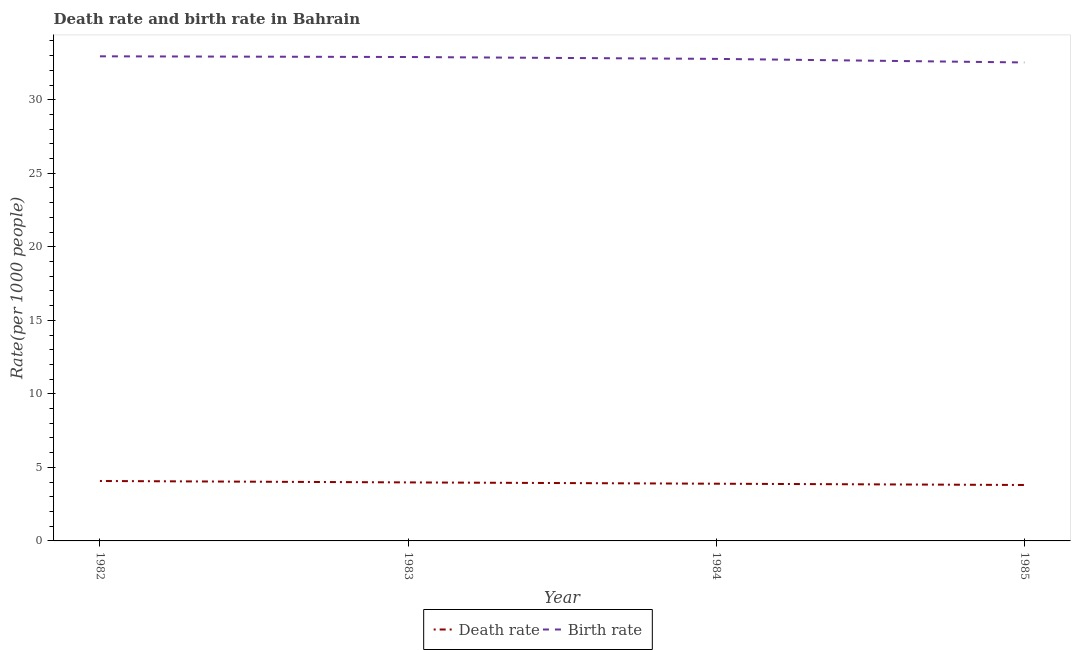Is the number of lines equal to the number of legend labels?
Your answer should be compact. Yes. What is the death rate in 1982?
Your answer should be very brief. 4.08. Across all years, what is the maximum birth rate?
Your response must be concise. 32.95. Across all years, what is the minimum birth rate?
Ensure brevity in your answer.  32.53. In which year was the birth rate minimum?
Make the answer very short. 1985. What is the total death rate in the graph?
Your answer should be compact. 15.75. What is the difference between the birth rate in 1982 and that in 1983?
Your answer should be compact. 0.05. What is the difference between the birth rate in 1982 and the death rate in 1984?
Keep it short and to the point. 29.06. What is the average death rate per year?
Your answer should be compact. 3.94. In the year 1983, what is the difference between the death rate and birth rate?
Make the answer very short. -28.92. What is the ratio of the death rate in 1984 to that in 1985?
Provide a short and direct response. 1.02. What is the difference between the highest and the second highest birth rate?
Give a very brief answer. 0.05. What is the difference between the highest and the lowest birth rate?
Ensure brevity in your answer.  0.42. In how many years, is the birth rate greater than the average birth rate taken over all years?
Your answer should be compact. 2. Is the sum of the death rate in 1982 and 1983 greater than the maximum birth rate across all years?
Provide a succinct answer. No. Is the birth rate strictly greater than the death rate over the years?
Ensure brevity in your answer.  Yes. How many years are there in the graph?
Ensure brevity in your answer.  4. What is the difference between two consecutive major ticks on the Y-axis?
Provide a succinct answer. 5. Does the graph contain any zero values?
Offer a terse response. No. How are the legend labels stacked?
Provide a short and direct response. Horizontal. What is the title of the graph?
Your response must be concise. Death rate and birth rate in Bahrain. What is the label or title of the X-axis?
Provide a succinct answer. Year. What is the label or title of the Y-axis?
Offer a very short reply. Rate(per 1000 people). What is the Rate(per 1000 people) in Death rate in 1982?
Provide a short and direct response. 4.08. What is the Rate(per 1000 people) in Birth rate in 1982?
Ensure brevity in your answer.  32.95. What is the Rate(per 1000 people) of Death rate in 1983?
Your answer should be compact. 3.98. What is the Rate(per 1000 people) of Birth rate in 1983?
Provide a short and direct response. 32.9. What is the Rate(per 1000 people) in Death rate in 1984?
Your response must be concise. 3.89. What is the Rate(per 1000 people) of Birth rate in 1984?
Your response must be concise. 32.78. What is the Rate(per 1000 people) of Death rate in 1985?
Your answer should be very brief. 3.8. What is the Rate(per 1000 people) in Birth rate in 1985?
Provide a short and direct response. 32.53. Across all years, what is the maximum Rate(per 1000 people) in Death rate?
Ensure brevity in your answer.  4.08. Across all years, what is the maximum Rate(per 1000 people) in Birth rate?
Give a very brief answer. 32.95. Across all years, what is the minimum Rate(per 1000 people) of Death rate?
Your answer should be compact. 3.8. Across all years, what is the minimum Rate(per 1000 people) of Birth rate?
Your answer should be compact. 32.53. What is the total Rate(per 1000 people) of Death rate in the graph?
Your response must be concise. 15.75. What is the total Rate(per 1000 people) of Birth rate in the graph?
Give a very brief answer. 131.16. What is the difference between the Rate(per 1000 people) of Death rate in 1982 and that in 1983?
Your answer should be very brief. 0.1. What is the difference between the Rate(per 1000 people) in Birth rate in 1982 and that in 1983?
Provide a short and direct response. 0.05. What is the difference between the Rate(per 1000 people) in Death rate in 1982 and that in 1984?
Give a very brief answer. 0.18. What is the difference between the Rate(per 1000 people) of Birth rate in 1982 and that in 1984?
Offer a very short reply. 0.17. What is the difference between the Rate(per 1000 people) in Death rate in 1982 and that in 1985?
Offer a terse response. 0.27. What is the difference between the Rate(per 1000 people) of Birth rate in 1982 and that in 1985?
Your answer should be compact. 0.42. What is the difference between the Rate(per 1000 people) in Death rate in 1983 and that in 1984?
Your answer should be compact. 0.09. What is the difference between the Rate(per 1000 people) in Birth rate in 1983 and that in 1984?
Make the answer very short. 0.13. What is the difference between the Rate(per 1000 people) of Death rate in 1983 and that in 1985?
Your response must be concise. 0.18. What is the difference between the Rate(per 1000 people) of Birth rate in 1983 and that in 1985?
Provide a succinct answer. 0.37. What is the difference between the Rate(per 1000 people) of Death rate in 1984 and that in 1985?
Provide a succinct answer. 0.09. What is the difference between the Rate(per 1000 people) of Birth rate in 1984 and that in 1985?
Give a very brief answer. 0.24. What is the difference between the Rate(per 1000 people) in Death rate in 1982 and the Rate(per 1000 people) in Birth rate in 1983?
Make the answer very short. -28.83. What is the difference between the Rate(per 1000 people) in Death rate in 1982 and the Rate(per 1000 people) in Birth rate in 1984?
Ensure brevity in your answer.  -28.7. What is the difference between the Rate(per 1000 people) in Death rate in 1982 and the Rate(per 1000 people) in Birth rate in 1985?
Make the answer very short. -28.46. What is the difference between the Rate(per 1000 people) of Death rate in 1983 and the Rate(per 1000 people) of Birth rate in 1984?
Offer a terse response. -28.8. What is the difference between the Rate(per 1000 people) in Death rate in 1983 and the Rate(per 1000 people) in Birth rate in 1985?
Provide a succinct answer. -28.55. What is the difference between the Rate(per 1000 people) in Death rate in 1984 and the Rate(per 1000 people) in Birth rate in 1985?
Make the answer very short. -28.64. What is the average Rate(per 1000 people) in Death rate per year?
Your answer should be very brief. 3.94. What is the average Rate(per 1000 people) of Birth rate per year?
Your response must be concise. 32.79. In the year 1982, what is the difference between the Rate(per 1000 people) of Death rate and Rate(per 1000 people) of Birth rate?
Offer a very short reply. -28.88. In the year 1983, what is the difference between the Rate(per 1000 people) in Death rate and Rate(per 1000 people) in Birth rate?
Offer a very short reply. -28.92. In the year 1984, what is the difference between the Rate(per 1000 people) of Death rate and Rate(per 1000 people) of Birth rate?
Keep it short and to the point. -28.89. In the year 1985, what is the difference between the Rate(per 1000 people) of Death rate and Rate(per 1000 people) of Birth rate?
Ensure brevity in your answer.  -28.73. What is the ratio of the Rate(per 1000 people) of Death rate in 1982 to that in 1983?
Your answer should be compact. 1.02. What is the ratio of the Rate(per 1000 people) of Death rate in 1982 to that in 1984?
Provide a succinct answer. 1.05. What is the ratio of the Rate(per 1000 people) of Birth rate in 1982 to that in 1984?
Give a very brief answer. 1.01. What is the ratio of the Rate(per 1000 people) in Death rate in 1982 to that in 1985?
Your response must be concise. 1.07. What is the ratio of the Rate(per 1000 people) of Birth rate in 1982 to that in 1985?
Ensure brevity in your answer.  1.01. What is the ratio of the Rate(per 1000 people) in Death rate in 1983 to that in 1984?
Offer a very short reply. 1.02. What is the ratio of the Rate(per 1000 people) in Death rate in 1983 to that in 1985?
Give a very brief answer. 1.05. What is the ratio of the Rate(per 1000 people) of Birth rate in 1983 to that in 1985?
Make the answer very short. 1.01. What is the ratio of the Rate(per 1000 people) in Death rate in 1984 to that in 1985?
Your response must be concise. 1.02. What is the ratio of the Rate(per 1000 people) of Birth rate in 1984 to that in 1985?
Make the answer very short. 1.01. What is the difference between the highest and the second highest Rate(per 1000 people) of Death rate?
Provide a succinct answer. 0.1. What is the difference between the highest and the second highest Rate(per 1000 people) in Birth rate?
Your response must be concise. 0.05. What is the difference between the highest and the lowest Rate(per 1000 people) of Death rate?
Your response must be concise. 0.27. What is the difference between the highest and the lowest Rate(per 1000 people) of Birth rate?
Offer a very short reply. 0.42. 